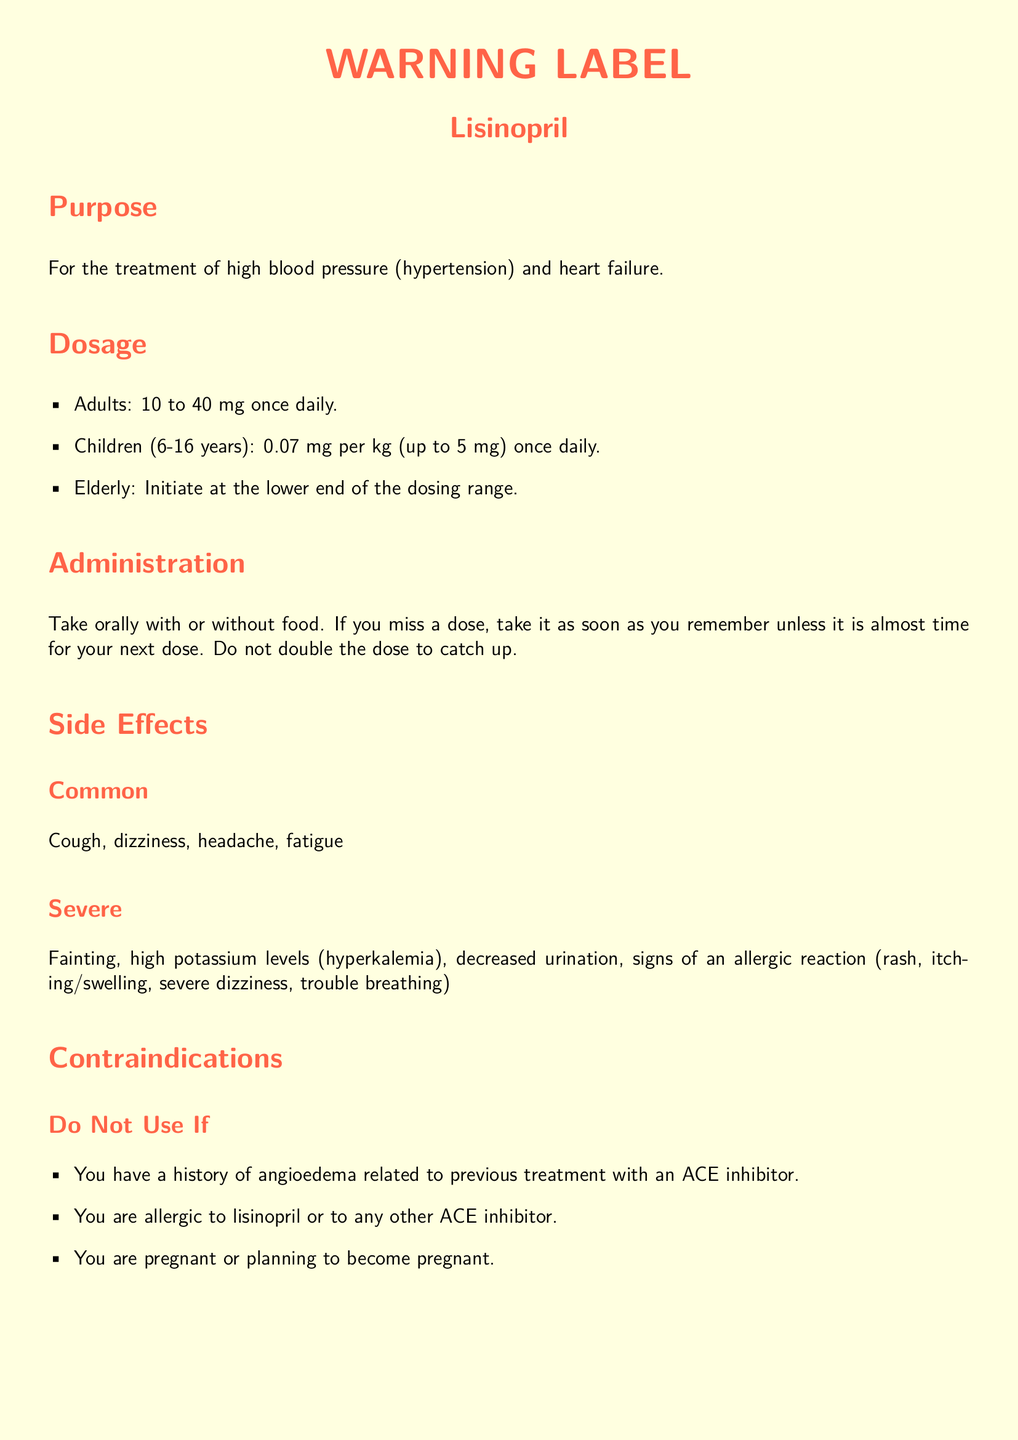what is the medication name? The medication name is listed prominently at the top of the document.
Answer: Lisinopril what is the adult dosage range? The dosage section specifies the dosage range for adults.
Answer: 10 to 40 mg what should you do if you miss a dose? The administration section provides instructions for missed doses.
Answer: Take it as soon as you remember what is a common side effect? The side effects section lists common and severe effects.
Answer: Cough what is one of the contraindications? The contraindications section specifies conditions under which the drug should not be used.
Answer: History of angioedema what should you consult a doctor about? The document details conditions for which a doctor should be consulted.
Answer: Kidney disease or are on dialysis what type of warning is highlighted? The document includes a specific warning label that is emphasized.
Answer: BLACK BOX WARNING what is the general warning regarding storage? The general warning section mentions how to store the medication.
Answer: Store at room temperature away from light and moisture 